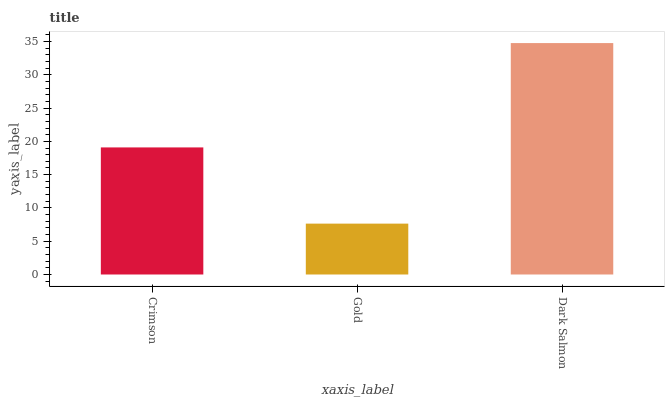Is Gold the minimum?
Answer yes or no. Yes. Is Dark Salmon the maximum?
Answer yes or no. Yes. Is Dark Salmon the minimum?
Answer yes or no. No. Is Gold the maximum?
Answer yes or no. No. Is Dark Salmon greater than Gold?
Answer yes or no. Yes. Is Gold less than Dark Salmon?
Answer yes or no. Yes. Is Gold greater than Dark Salmon?
Answer yes or no. No. Is Dark Salmon less than Gold?
Answer yes or no. No. Is Crimson the high median?
Answer yes or no. Yes. Is Crimson the low median?
Answer yes or no. Yes. Is Gold the high median?
Answer yes or no. No. Is Dark Salmon the low median?
Answer yes or no. No. 